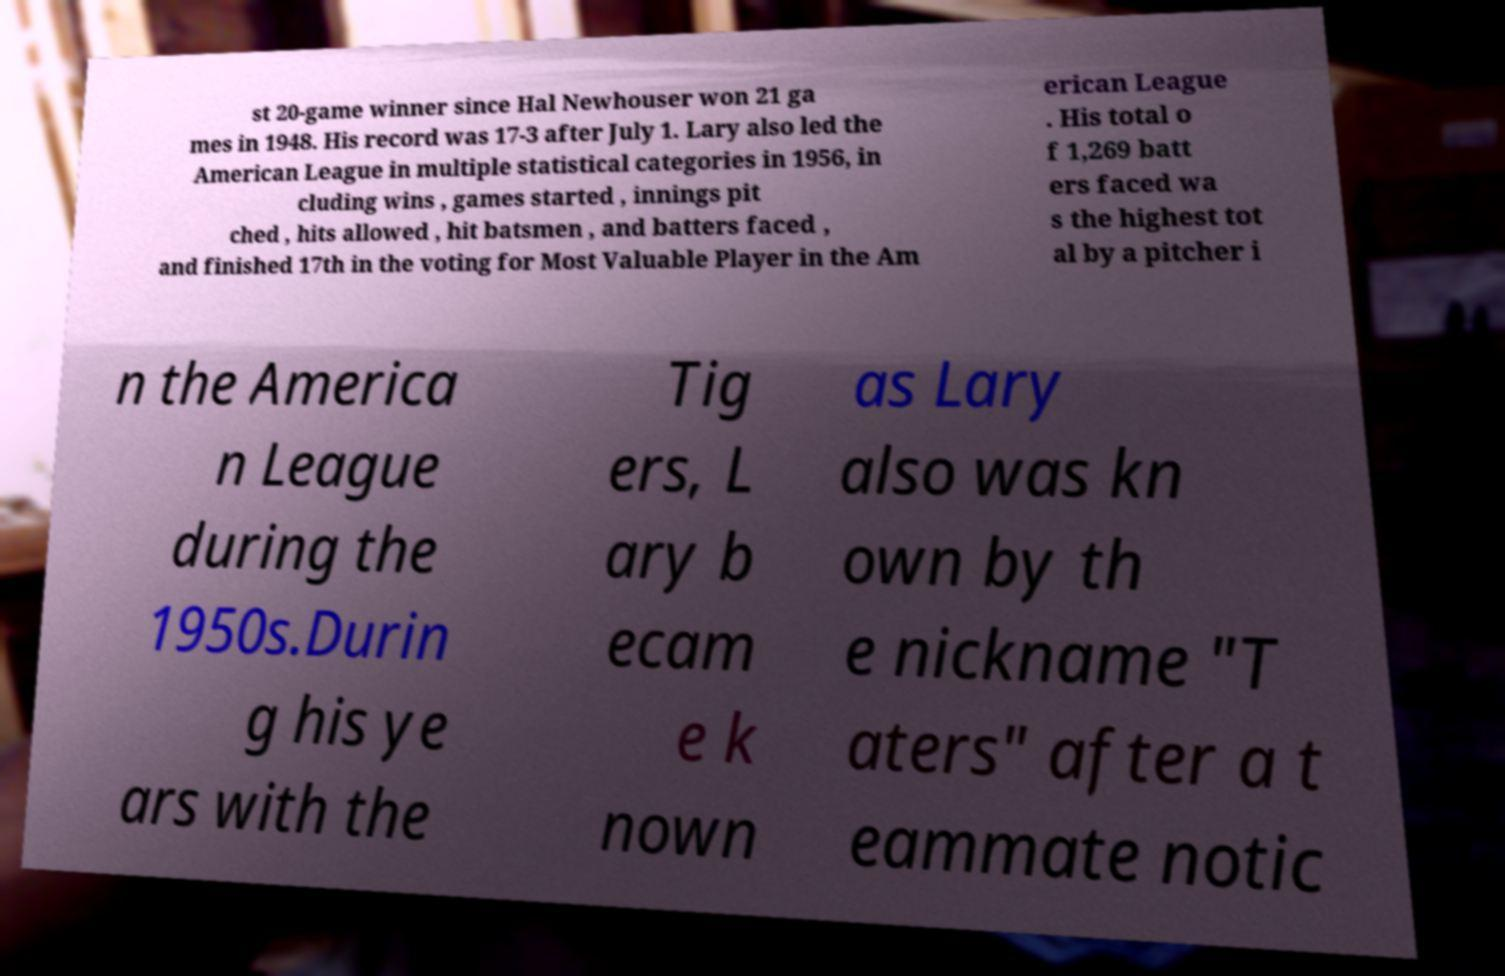There's text embedded in this image that I need extracted. Can you transcribe it verbatim? st 20-game winner since Hal Newhouser won 21 ga mes in 1948. His record was 17-3 after July 1. Lary also led the American League in multiple statistical categories in 1956, in cluding wins , games started , innings pit ched , hits allowed , hit batsmen , and batters faced , and finished 17th in the voting for Most Valuable Player in the Am erican League . His total o f 1,269 batt ers faced wa s the highest tot al by a pitcher i n the America n League during the 1950s.Durin g his ye ars with the Tig ers, L ary b ecam e k nown as Lary also was kn own by th e nickname "T aters" after a t eammate notic 